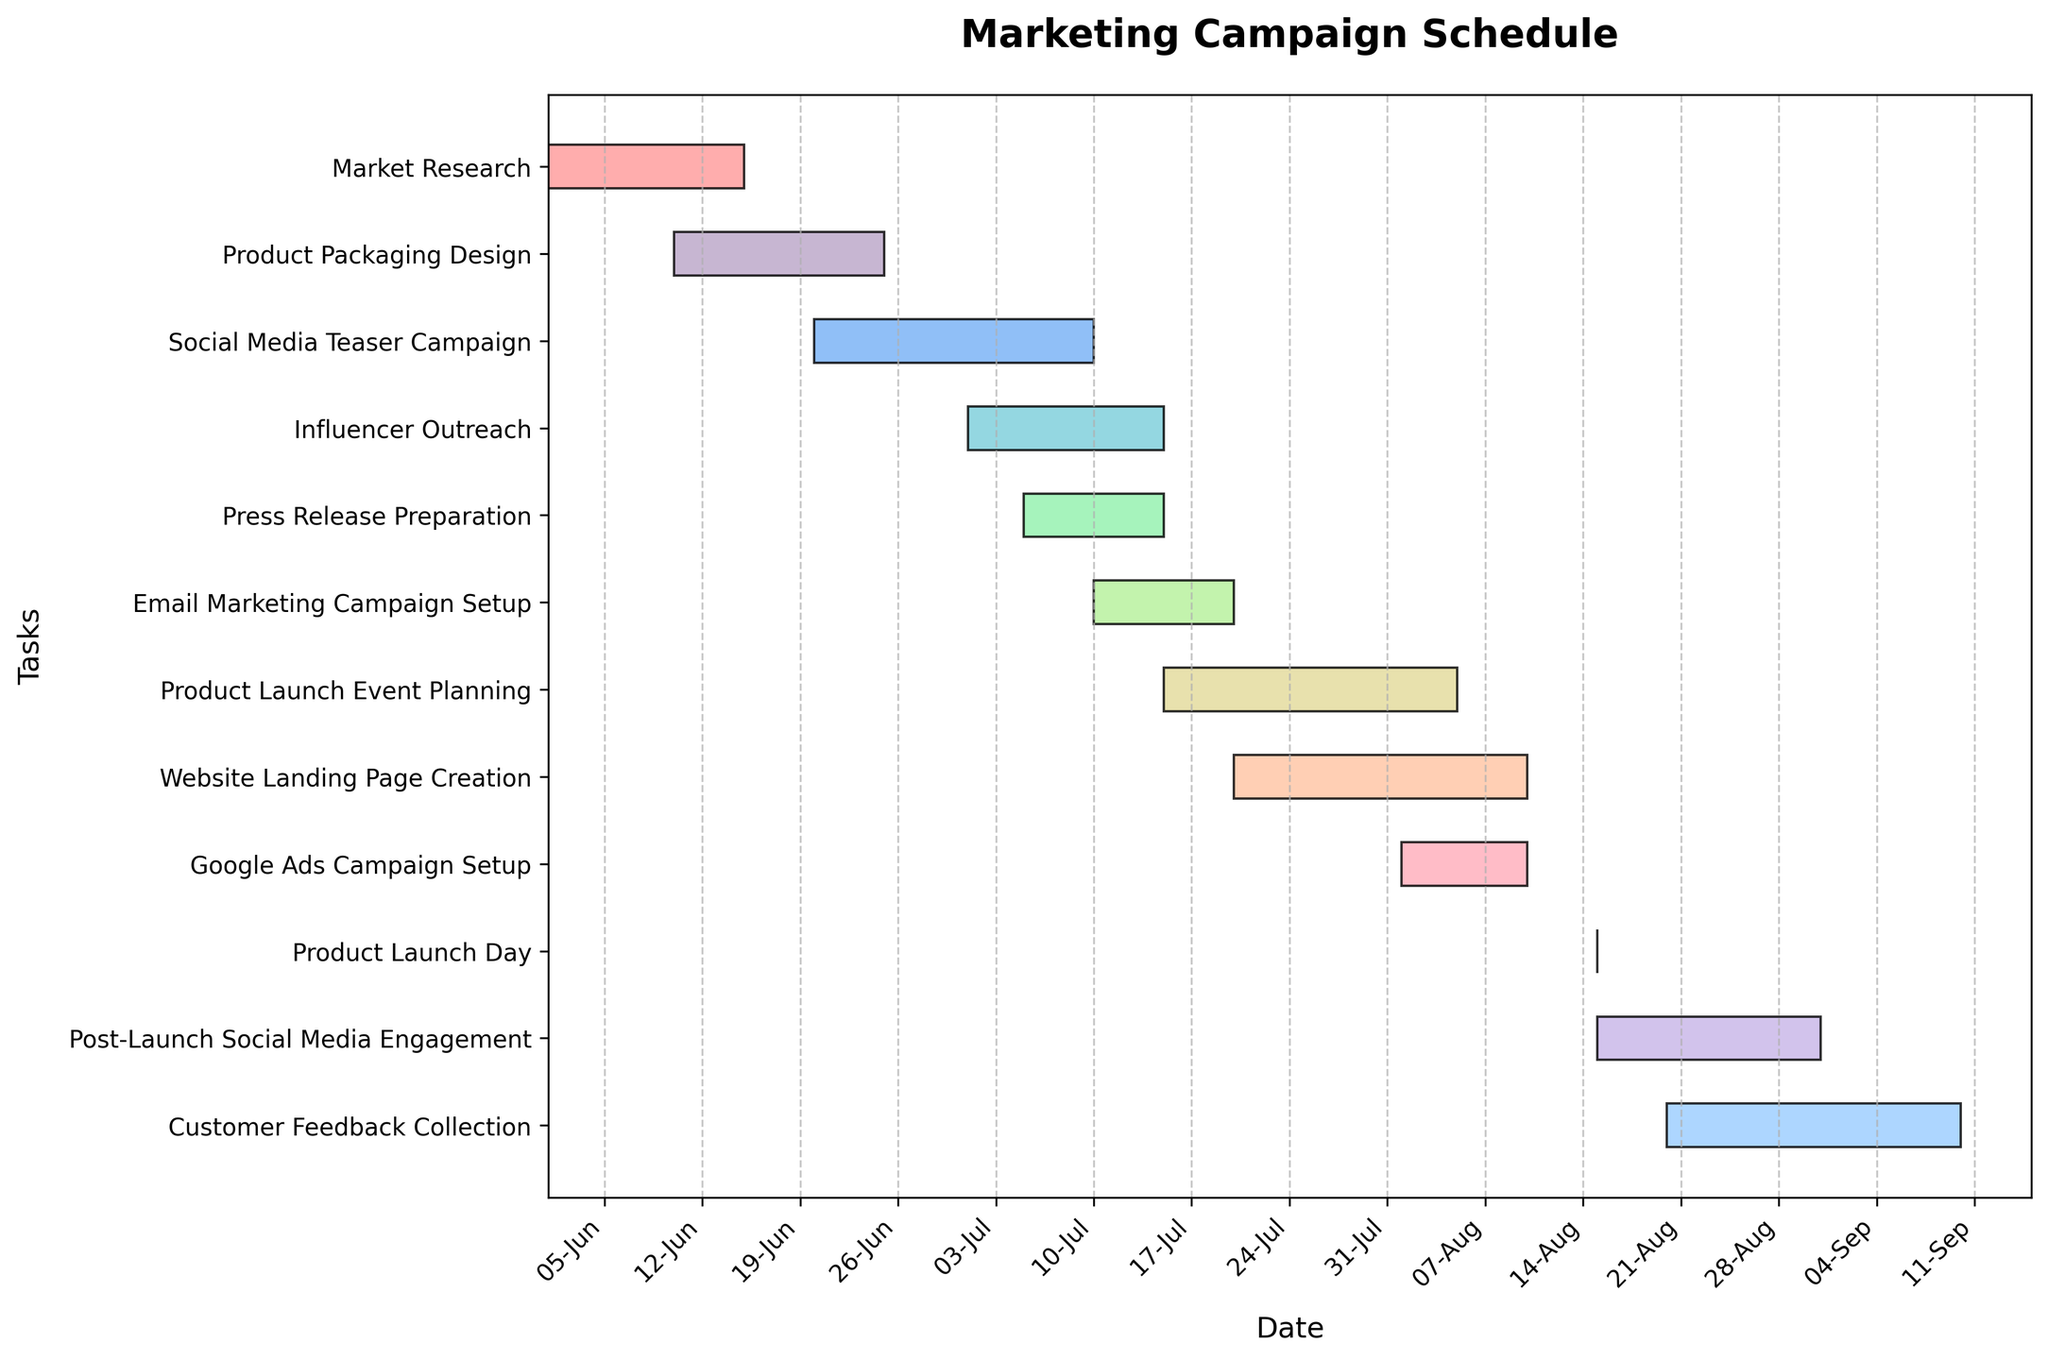What's the title of the Gantt Chart? The title is typically displayed at the top of the Gantt Chart. By reading this area, you can find the title.
Answer: Marketing Campaign Schedule What are the start and end dates of the 'Google Ads Campaign Setup' task? Look at the 'Google Ads Campaign Setup' row and read the labels at the beginning and end of the bar corresponding to this task.
Answer: 2023-08-01 and 2023-08-10 Which task has the longest duration? Compare the lengths of all bars in the chart and identify the longest one.
Answer: Product Launch Event Planning How many tasks are scheduled to start in July? Count the number of tasks whose start dates fall within the month of July on the x-axis.
Answer: 6 tasks Is there any task that starts and ends within the same month? Identify bars that lie entirely within a single month based on the x-axis labels. Task bars in the month of August that fit this criterion are one example.
Answer: Yes, 'Google Ads Campaign Setup' starts and ends in August Which task immediately follows 'Social Media Teaser Campaign'? Look at the end date of the 'Social Media Teaser Campaign' bar and find the next task that starts right after this date.
Answer: Influencer Outreach Are there any overlapping tasks? Look for instances where the bars corresponding to different tasks are layered on top of each other on the y-axis, indicating they occur simultaneously. For example, 'Email Marketing Campaign Setup' overlaps with 'Product Launch Event Planning.'
Answer: Yes When does 'Post-Launch Social Media Engagement' start and end? Locate the bar labeled 'Post-Launch Social Media Engagement' and check its starting and ending points on the x-axis.
Answer: 2023-08-15 and 2023-08-31 Which task ends on the same day as it starts? Identify the tasks with bars that have no visible length, meaning their start and end dates are the same.
Answer: Product Launch Day starts and ends on 2023-08-15 How many days after the 'Market Research' ends does the 'Product Launch Day' occur? First, find the end date of 'Market Research' and the start date of 'Product Launch Day.' Then, calculate the difference between these two dates.
Answer: 61 days 